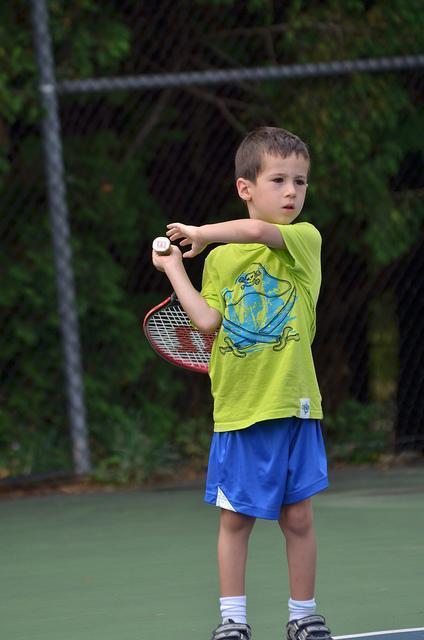How many tennis rackets are in the photo?
Give a very brief answer. 1. 